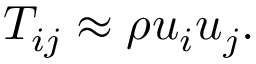Convert formula to latex. <formula><loc_0><loc_0><loc_500><loc_500>T _ { i j } \approx \rho u _ { i } u _ { j } .</formula> 